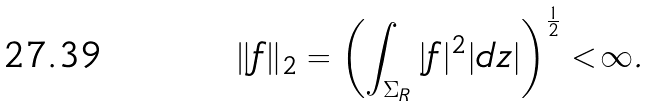<formula> <loc_0><loc_0><loc_500><loc_500>\| f \| _ { 2 } = \left ( \int _ { \Sigma _ { R } } | f | ^ { 2 } | d z | \right ) ^ { \frac { 1 } { 2 } } < \infty .</formula> 